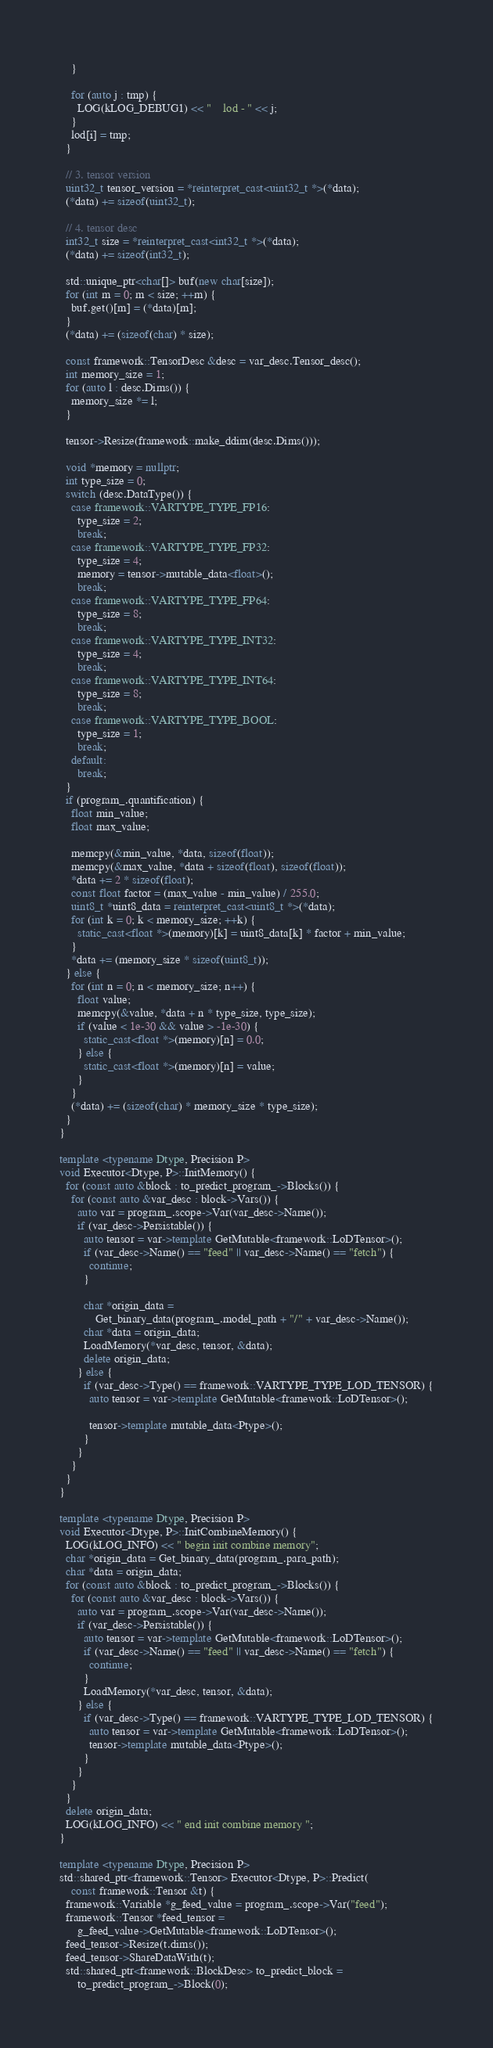Convert code to text. <code><loc_0><loc_0><loc_500><loc_500><_C++_>    }

    for (auto j : tmp) {
      LOG(kLOG_DEBUG1) << "    lod - " << j;
    }
    lod[i] = tmp;
  }

  // 3. tensor version
  uint32_t tensor_version = *reinterpret_cast<uint32_t *>(*data);
  (*data) += sizeof(uint32_t);

  // 4. tensor desc
  int32_t size = *reinterpret_cast<int32_t *>(*data);
  (*data) += sizeof(int32_t);

  std::unique_ptr<char[]> buf(new char[size]);
  for (int m = 0; m < size; ++m) {
    buf.get()[m] = (*data)[m];
  }
  (*data) += (sizeof(char) * size);

  const framework::TensorDesc &desc = var_desc.Tensor_desc();
  int memory_size = 1;
  for (auto l : desc.Dims()) {
    memory_size *= l;
  }

  tensor->Resize(framework::make_ddim(desc.Dims()));

  void *memory = nullptr;
  int type_size = 0;
  switch (desc.DataType()) {
    case framework::VARTYPE_TYPE_FP16:
      type_size = 2;
      break;
    case framework::VARTYPE_TYPE_FP32:
      type_size = 4;
      memory = tensor->mutable_data<float>();
      break;
    case framework::VARTYPE_TYPE_FP64:
      type_size = 8;
      break;
    case framework::VARTYPE_TYPE_INT32:
      type_size = 4;
      break;
    case framework::VARTYPE_TYPE_INT64:
      type_size = 8;
      break;
    case framework::VARTYPE_TYPE_BOOL:
      type_size = 1;
      break;
    default:
      break;
  }
  if (program_.quantification) {
    float min_value;
    float max_value;

    memcpy(&min_value, *data, sizeof(float));
    memcpy(&max_value, *data + sizeof(float), sizeof(float));
    *data += 2 * sizeof(float);
    const float factor = (max_value - min_value) / 255.0;
    uint8_t *uint8_data = reinterpret_cast<uint8_t *>(*data);
    for (int k = 0; k < memory_size; ++k) {
      static_cast<float *>(memory)[k] = uint8_data[k] * factor + min_value;
    }
    *data += (memory_size * sizeof(uint8_t));
  } else {
    for (int n = 0; n < memory_size; n++) {
      float value;
      memcpy(&value, *data + n * type_size, type_size);
      if (value < 1e-30 && value > -1e-30) {
        static_cast<float *>(memory)[n] = 0.0;
      } else {
        static_cast<float *>(memory)[n] = value;
      }
    }
    (*data) += (sizeof(char) * memory_size * type_size);
  }
}

template <typename Dtype, Precision P>
void Executor<Dtype, P>::InitMemory() {
  for (const auto &block : to_predict_program_->Blocks()) {
    for (const auto &var_desc : block->Vars()) {
      auto var = program_.scope->Var(var_desc->Name());
      if (var_desc->Persistable()) {
        auto tensor = var->template GetMutable<framework::LoDTensor>();
        if (var_desc->Name() == "feed" || var_desc->Name() == "fetch") {
          continue;
        }

        char *origin_data =
            Get_binary_data(program_.model_path + "/" + var_desc->Name());
        char *data = origin_data;
        LoadMemory(*var_desc, tensor, &data);
        delete origin_data;
      } else {
        if (var_desc->Type() == framework::VARTYPE_TYPE_LOD_TENSOR) {
          auto tensor = var->template GetMutable<framework::LoDTensor>();

          tensor->template mutable_data<Ptype>();
        }
      }
    }
  }
}

template <typename Dtype, Precision P>
void Executor<Dtype, P>::InitCombineMemory() {
  LOG(kLOG_INFO) << " begin init combine memory";
  char *origin_data = Get_binary_data(program_.para_path);
  char *data = origin_data;
  for (const auto &block : to_predict_program_->Blocks()) {
    for (const auto &var_desc : block->Vars()) {
      auto var = program_.scope->Var(var_desc->Name());
      if (var_desc->Persistable()) {
        auto tensor = var->template GetMutable<framework::LoDTensor>();
        if (var_desc->Name() == "feed" || var_desc->Name() == "fetch") {
          continue;
        }
        LoadMemory(*var_desc, tensor, &data);
      } else {
        if (var_desc->Type() == framework::VARTYPE_TYPE_LOD_TENSOR) {
          auto tensor = var->template GetMutable<framework::LoDTensor>();
          tensor->template mutable_data<Ptype>();
        }
      }
    }
  }
  delete origin_data;
  LOG(kLOG_INFO) << " end init combine memory ";
}

template <typename Dtype, Precision P>
std::shared_ptr<framework::Tensor> Executor<Dtype, P>::Predict(
    const framework::Tensor &t) {
  framework::Variable *g_feed_value = program_.scope->Var("feed");
  framework::Tensor *feed_tensor =
      g_feed_value->GetMutable<framework::LoDTensor>();
  feed_tensor->Resize(t.dims());
  feed_tensor->ShareDataWith(t);
  std::shared_ptr<framework::BlockDesc> to_predict_block =
      to_predict_program_->Block(0);</code> 